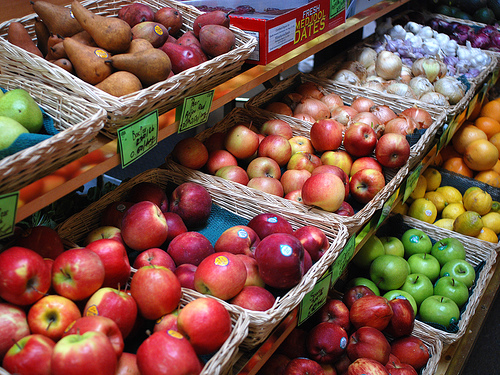Identify the text contained in this image. MEDJOOL DATES 